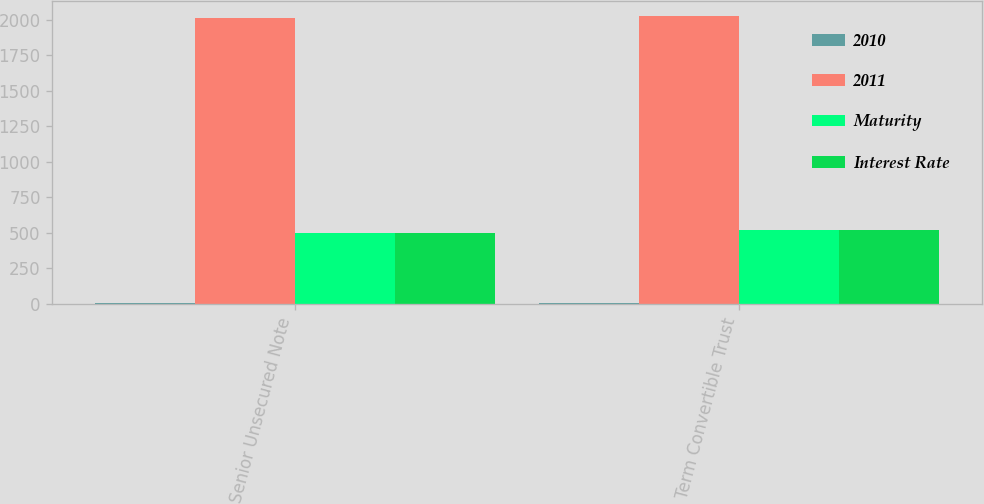Convert chart to OTSL. <chart><loc_0><loc_0><loc_500><loc_500><stacked_bar_chart><ecel><fcel>Senior Unsecured Note<fcel>Term Convertible Trust<nl><fcel>2010<fcel>7.75<fcel>6.75<nl><fcel>2011<fcel>2014<fcel>2029<nl><fcel>Maturity<fcel>500<fcel>517<nl><fcel>Interest Rate<fcel>500<fcel>517<nl></chart> 